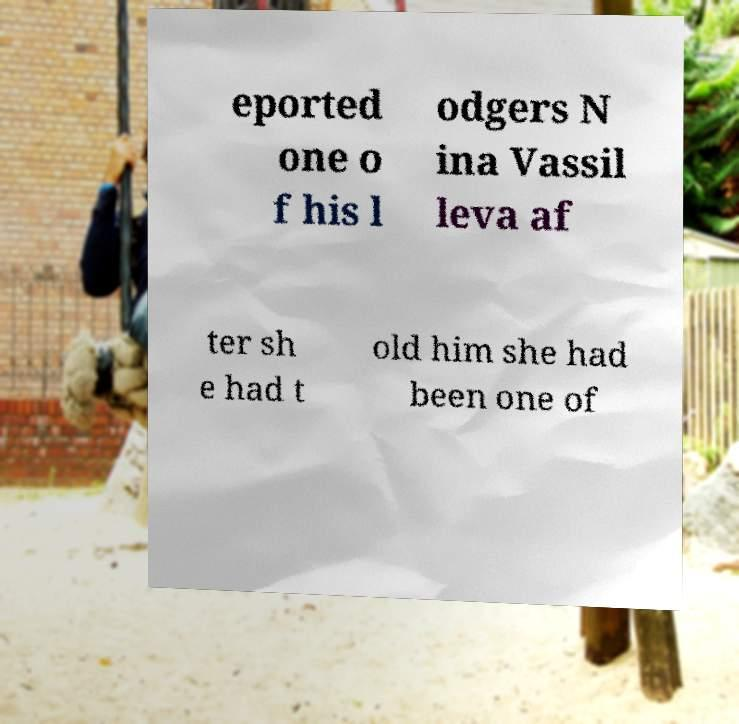I need the written content from this picture converted into text. Can you do that? eported one o f his l odgers N ina Vassil leva af ter sh e had t old him she had been one of 